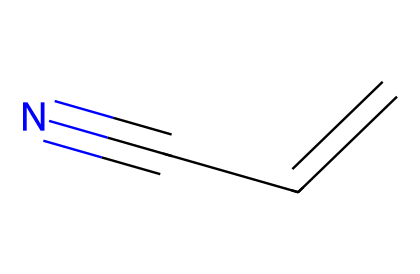What is the chemical name represented by this structure? The structure with the SMILES notation C=CC#N corresponds to acrylonitrile, which is a nitrile compound. Nitriles are characterized by the presence of a cyano group (-C≡N).
Answer: acrylonitrile How many carbon atoms are present in this molecule? The SMILES notation C=CC#N indicates that there are three carbon atoms (C) in the structure, each represented by the 'C' character in the notation.
Answer: three What type of chemical bond is present between the carbon atoms in this structure? In the given SMILES notation, the 'C=C' indicates a double bond between the two carbon atoms, while 'C#N' indicates a triple bond between the last carbon and the nitrogen atom.
Answer: double and triple bonds Which functional group is present in acrylonitrile? The presence of the cyano group (-C≡N) in the structure defines the functional group of nitriles. This functional group is responsible for the chemical reactivity and properties associated with acrylonitrile.
Answer: cyano group What is the molecular formula of acrylonitrile? The molecular formula is derived from the count of different atoms in the structure: three carbon atoms, three hydrogen atoms, and one nitrogen atom, leading to the formula C3H3N.
Answer: C3H3N What are the primary components contributing to the reactivity of this molecule? The carbon-carbon double bond (C=C) and the triple bond with nitrogen (C#N) are responsible for the reactivity of acrylonitrile, allowing it to participate in various chemical reactions, including polymerization.
Answer: double bond and triple bond Why is acrylonitrile important in the production of acrylic fibers? Acrylonitrile is polymerized to form polyacrylonitrile, which is a key material in producing acrylic fibers, commonly used for textiles, including stage costumes, due to its durability and aesthetic qualities.
Answer: polymerization to polyacrylonitrile 